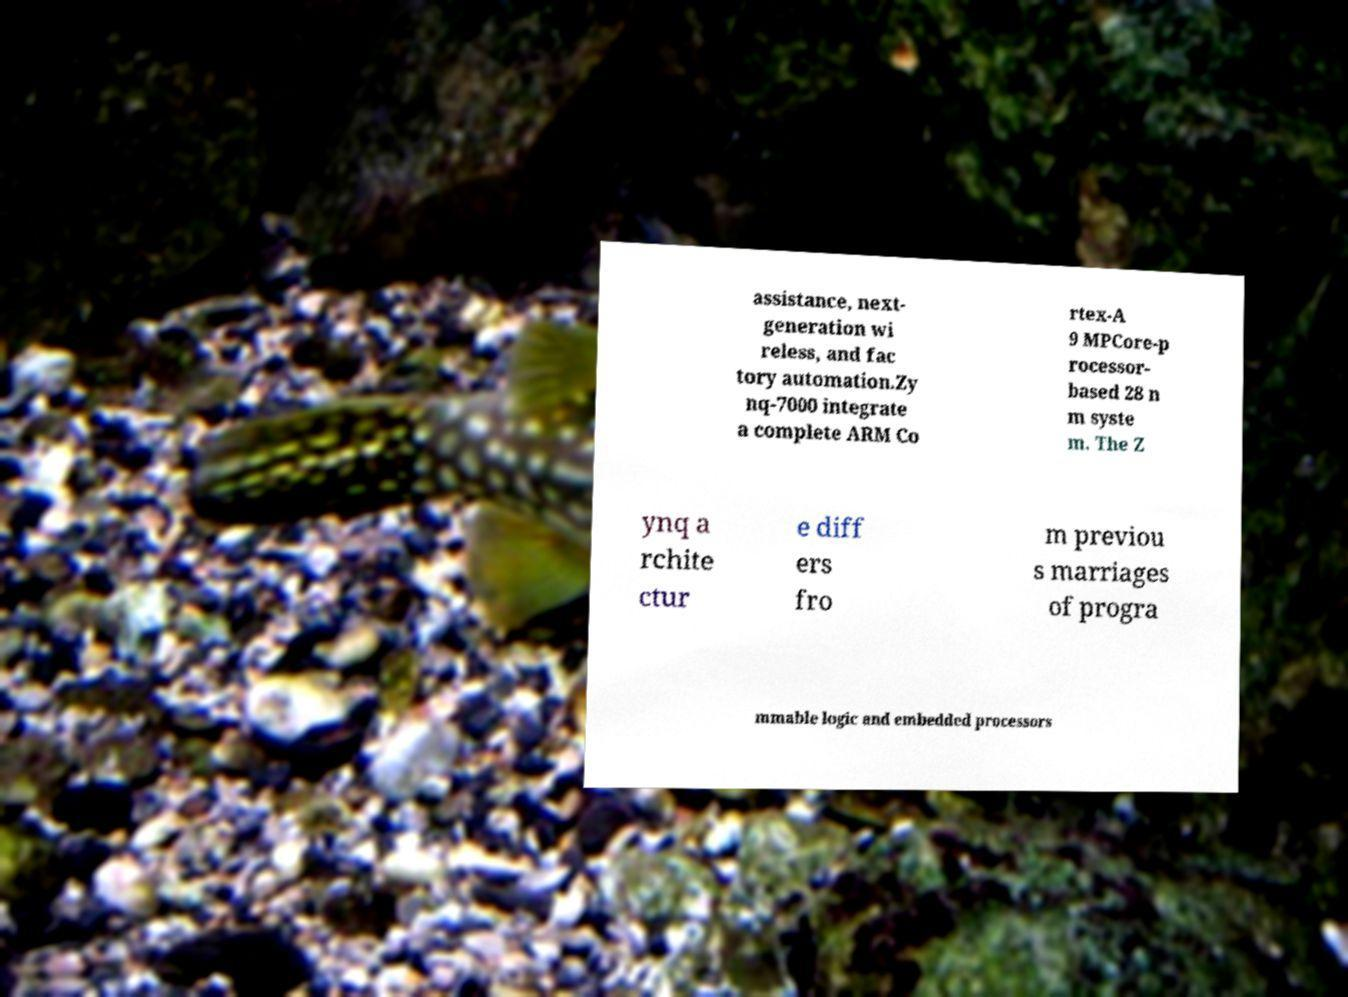I need the written content from this picture converted into text. Can you do that? assistance, next- generation wi reless, and fac tory automation.Zy nq-7000 integrate a complete ARM Co rtex-A 9 MPCore-p rocessor- based 28 n m syste m. The Z ynq a rchite ctur e diff ers fro m previou s marriages of progra mmable logic and embedded processors 